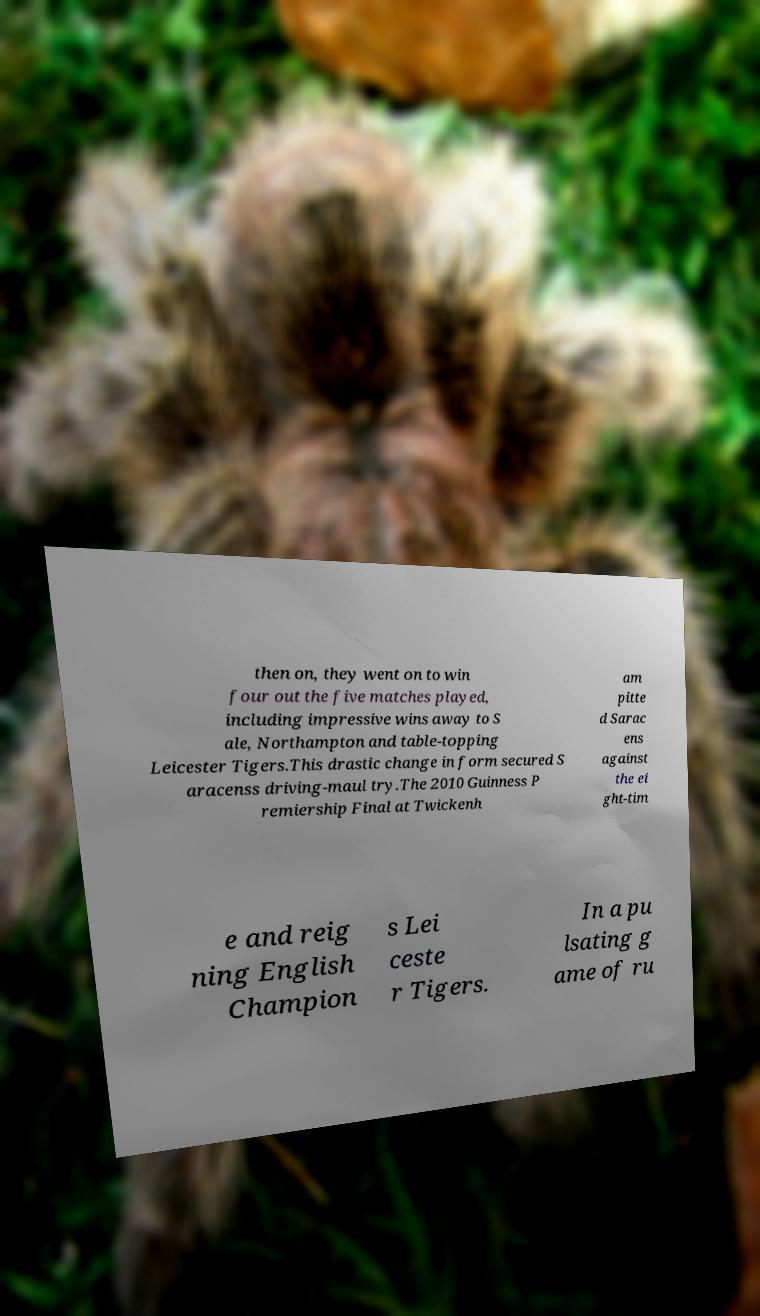Could you assist in decoding the text presented in this image and type it out clearly? then on, they went on to win four out the five matches played, including impressive wins away to S ale, Northampton and table-topping Leicester Tigers.This drastic change in form secured S aracenss driving-maul try.The 2010 Guinness P remiership Final at Twickenh am pitte d Sarac ens against the ei ght-tim e and reig ning English Champion s Lei ceste r Tigers. In a pu lsating g ame of ru 